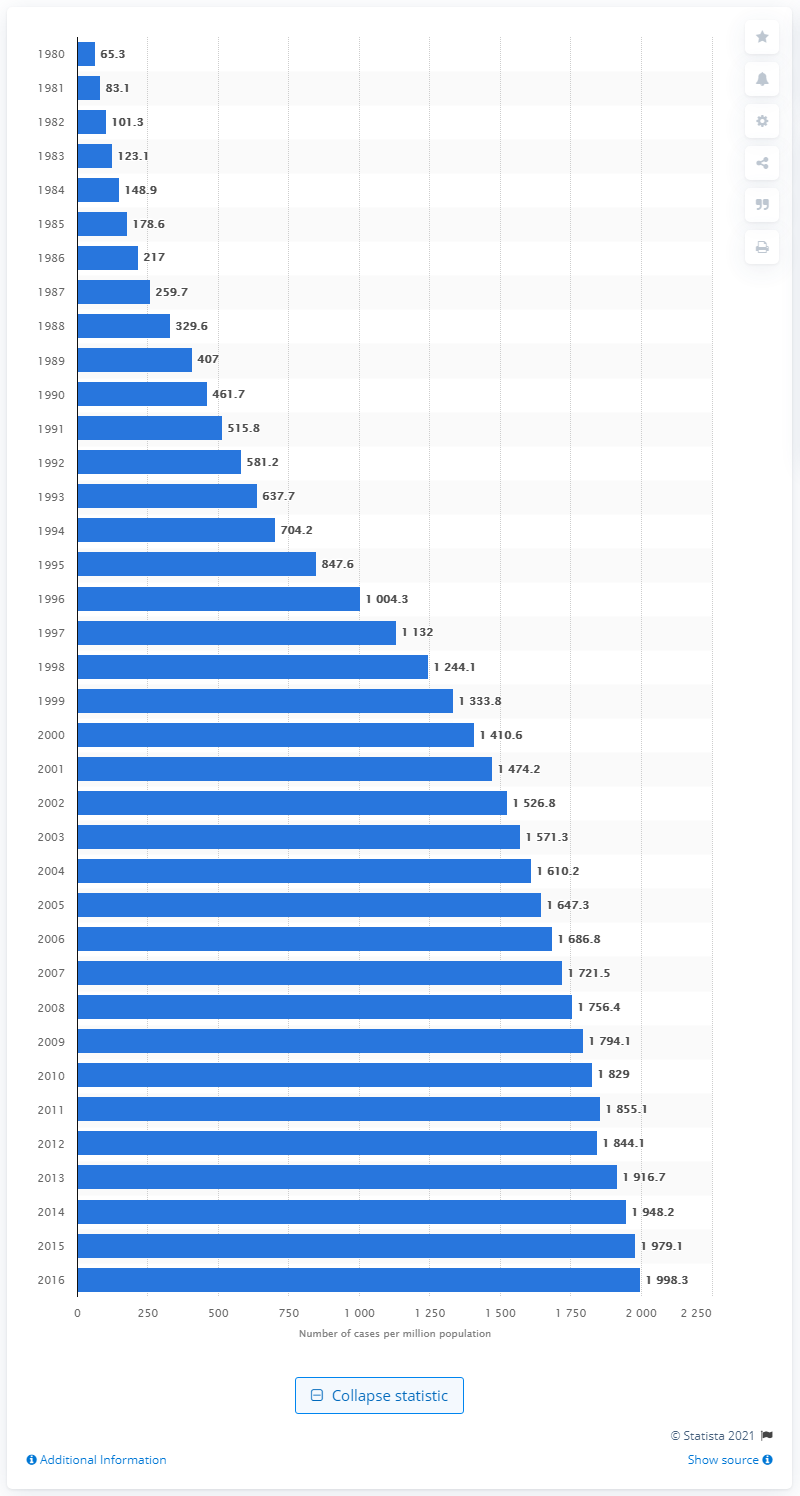Draw attention to some important aspects in this diagram. In the year 1998, there were approximately 0.3 cases of end-stage renal disease per one million people. In 1980, the rate of end-stage renal disease (ESRD) per one million people was 65.3. 